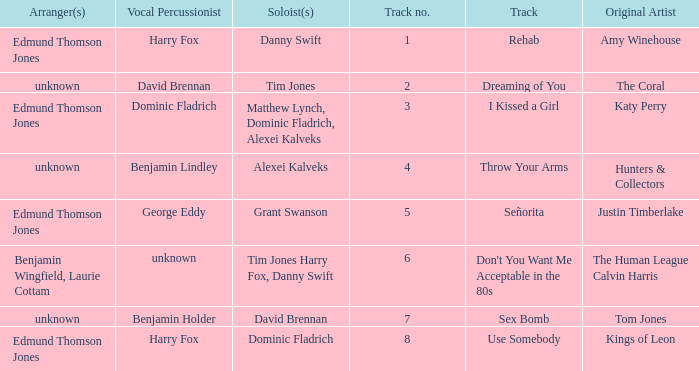Who is the arranger for "I KIssed a Girl"? Edmund Thomson Jones. 